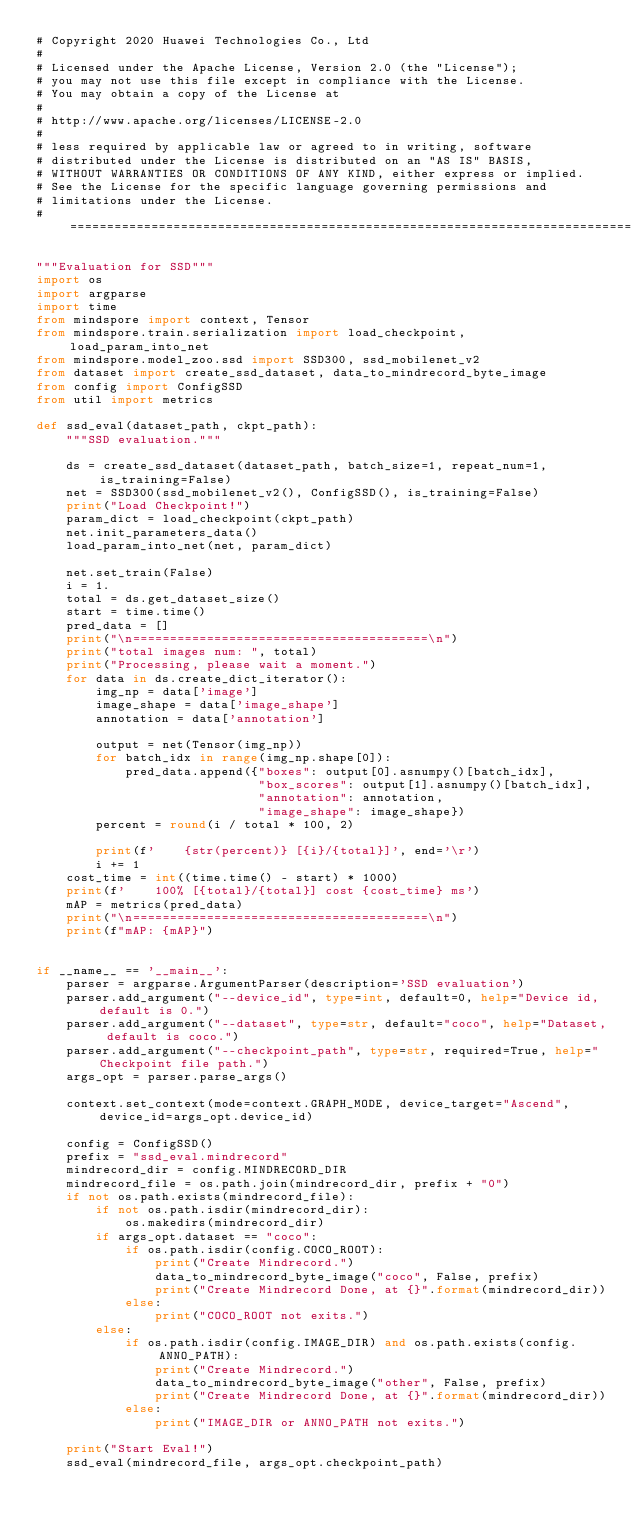<code> <loc_0><loc_0><loc_500><loc_500><_Python_># Copyright 2020 Huawei Technologies Co., Ltd
#
# Licensed under the Apache License, Version 2.0 (the "License");
# you may not use this file except in compliance with the License.
# You may obtain a copy of the License at
#
# http://www.apache.org/licenses/LICENSE-2.0
#
# less required by applicable law or agreed to in writing, software
# distributed under the License is distributed on an "AS IS" BASIS,
# WITHOUT WARRANTIES OR CONDITIONS OF ANY KIND, either express or implied.
# See the License for the specific language governing permissions and
# limitations under the License.
# ============================================================================

"""Evaluation for SSD"""
import os
import argparse
import time
from mindspore import context, Tensor
from mindspore.train.serialization import load_checkpoint, load_param_into_net
from mindspore.model_zoo.ssd import SSD300, ssd_mobilenet_v2
from dataset import create_ssd_dataset, data_to_mindrecord_byte_image
from config import ConfigSSD
from util import metrics

def ssd_eval(dataset_path, ckpt_path):
    """SSD evaluation."""

    ds = create_ssd_dataset(dataset_path, batch_size=1, repeat_num=1, is_training=False)
    net = SSD300(ssd_mobilenet_v2(), ConfigSSD(), is_training=False)
    print("Load Checkpoint!")
    param_dict = load_checkpoint(ckpt_path)
    net.init_parameters_data()
    load_param_into_net(net, param_dict)

    net.set_train(False)
    i = 1.
    total = ds.get_dataset_size()
    start = time.time()
    pred_data = []
    print("\n========================================\n")
    print("total images num: ", total)
    print("Processing, please wait a moment.")
    for data in ds.create_dict_iterator():
        img_np = data['image']
        image_shape = data['image_shape']
        annotation = data['annotation']

        output = net(Tensor(img_np))
        for batch_idx in range(img_np.shape[0]):
            pred_data.append({"boxes": output[0].asnumpy()[batch_idx],
                              "box_scores": output[1].asnumpy()[batch_idx],
                              "annotation": annotation,
                              "image_shape": image_shape})
        percent = round(i / total * 100, 2)

        print(f'    {str(percent)} [{i}/{total}]', end='\r')
        i += 1
    cost_time = int((time.time() - start) * 1000)
    print(f'    100% [{total}/{total}] cost {cost_time} ms')
    mAP = metrics(pred_data)
    print("\n========================================\n")
    print(f"mAP: {mAP}")


if __name__ == '__main__':
    parser = argparse.ArgumentParser(description='SSD evaluation')
    parser.add_argument("--device_id", type=int, default=0, help="Device id, default is 0.")
    parser.add_argument("--dataset", type=str, default="coco", help="Dataset, default is coco.")
    parser.add_argument("--checkpoint_path", type=str, required=True, help="Checkpoint file path.")
    args_opt = parser.parse_args()

    context.set_context(mode=context.GRAPH_MODE, device_target="Ascend", device_id=args_opt.device_id)

    config = ConfigSSD()
    prefix = "ssd_eval.mindrecord"
    mindrecord_dir = config.MINDRECORD_DIR
    mindrecord_file = os.path.join(mindrecord_dir, prefix + "0")
    if not os.path.exists(mindrecord_file):
        if not os.path.isdir(mindrecord_dir):
            os.makedirs(mindrecord_dir)
        if args_opt.dataset == "coco":
            if os.path.isdir(config.COCO_ROOT):
                print("Create Mindrecord.")
                data_to_mindrecord_byte_image("coco", False, prefix)
                print("Create Mindrecord Done, at {}".format(mindrecord_dir))
            else:
                print("COCO_ROOT not exits.")
        else:
            if os.path.isdir(config.IMAGE_DIR) and os.path.exists(config.ANNO_PATH):
                print("Create Mindrecord.")
                data_to_mindrecord_byte_image("other", False, prefix)
                print("Create Mindrecord Done, at {}".format(mindrecord_dir))
            else:
                print("IMAGE_DIR or ANNO_PATH not exits.")

    print("Start Eval!")
    ssd_eval(mindrecord_file, args_opt.checkpoint_path)
</code> 